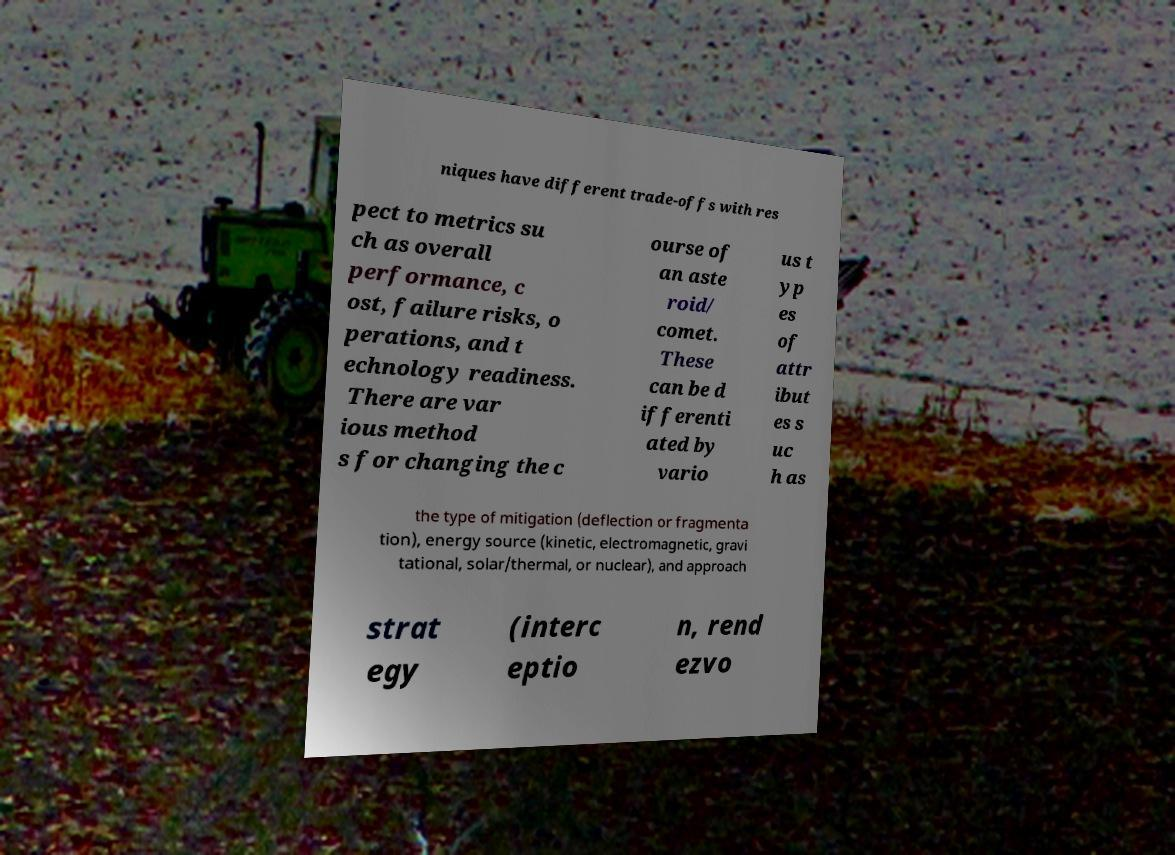I need the written content from this picture converted into text. Can you do that? niques have different trade-offs with res pect to metrics su ch as overall performance, c ost, failure risks, o perations, and t echnology readiness. There are var ious method s for changing the c ourse of an aste roid/ comet. These can be d ifferenti ated by vario us t yp es of attr ibut es s uc h as the type of mitigation (deflection or fragmenta tion), energy source (kinetic, electromagnetic, gravi tational, solar/thermal, or nuclear), and approach strat egy (interc eptio n, rend ezvo 